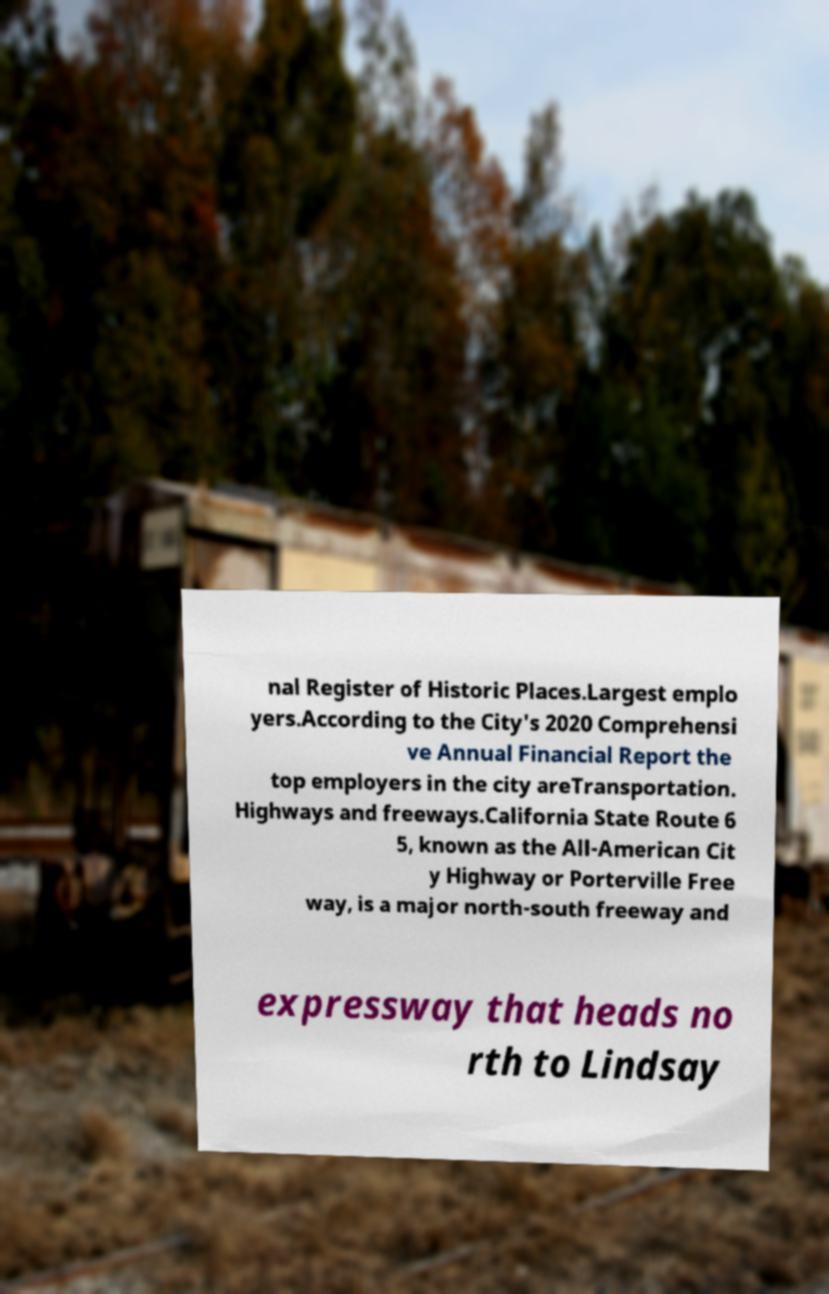Could you assist in decoding the text presented in this image and type it out clearly? nal Register of Historic Places.Largest emplo yers.According to the City's 2020 Comprehensi ve Annual Financial Report the top employers in the city areTransportation. Highways and freeways.California State Route 6 5, known as the All-American Cit y Highway or Porterville Free way, is a major north-south freeway and expressway that heads no rth to Lindsay 